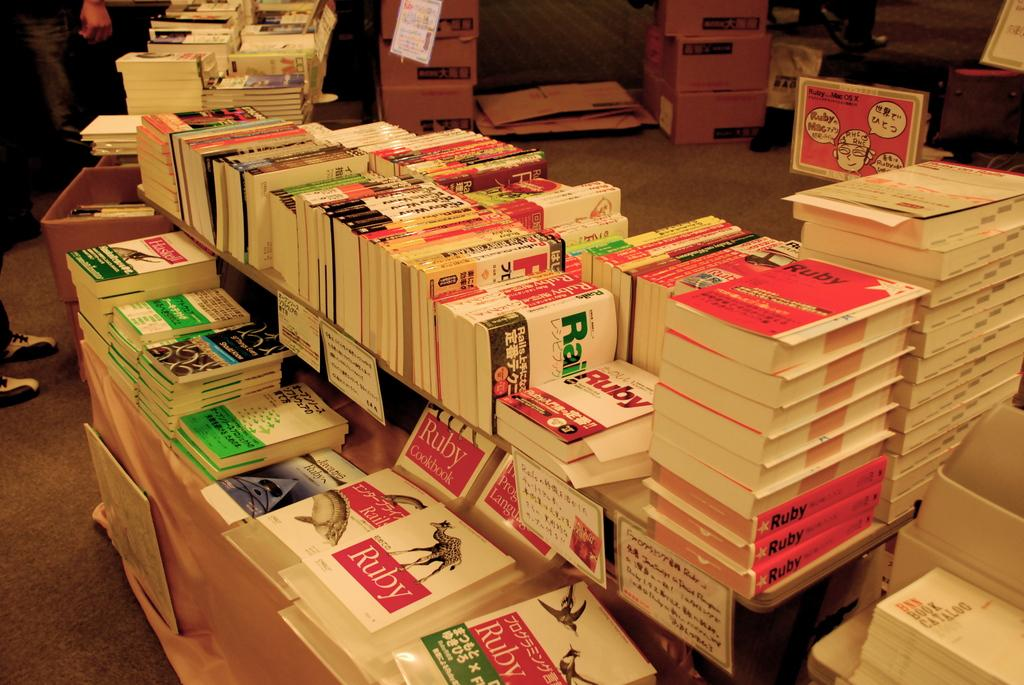<image>
Offer a succinct explanation of the picture presented. A variety of books are stacked on a table, some with the word Ruby on the cover. 